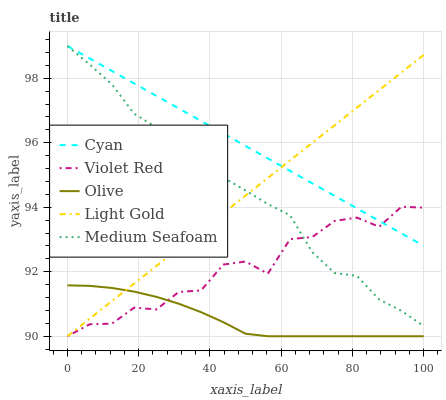Does Olive have the minimum area under the curve?
Answer yes or no. Yes. Does Cyan have the maximum area under the curve?
Answer yes or no. Yes. Does Violet Red have the minimum area under the curve?
Answer yes or no. No. Does Violet Red have the maximum area under the curve?
Answer yes or no. No. Is Cyan the smoothest?
Answer yes or no. Yes. Is Violet Red the roughest?
Answer yes or no. Yes. Is Violet Red the smoothest?
Answer yes or no. No. Is Cyan the roughest?
Answer yes or no. No. Does Olive have the lowest value?
Answer yes or no. Yes. Does Cyan have the lowest value?
Answer yes or no. No. Does Medium Seafoam have the highest value?
Answer yes or no. Yes. Does Violet Red have the highest value?
Answer yes or no. No. Is Olive less than Cyan?
Answer yes or no. Yes. Is Medium Seafoam greater than Olive?
Answer yes or no. Yes. Does Violet Red intersect Light Gold?
Answer yes or no. Yes. Is Violet Red less than Light Gold?
Answer yes or no. No. Is Violet Red greater than Light Gold?
Answer yes or no. No. Does Olive intersect Cyan?
Answer yes or no. No. 